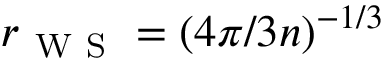Convert formula to latex. <formula><loc_0><loc_0><loc_500><loc_500>r _ { W S } = ( { 4 \pi } / { 3 n } ) ^ { - { 1 } / { 3 } }</formula> 